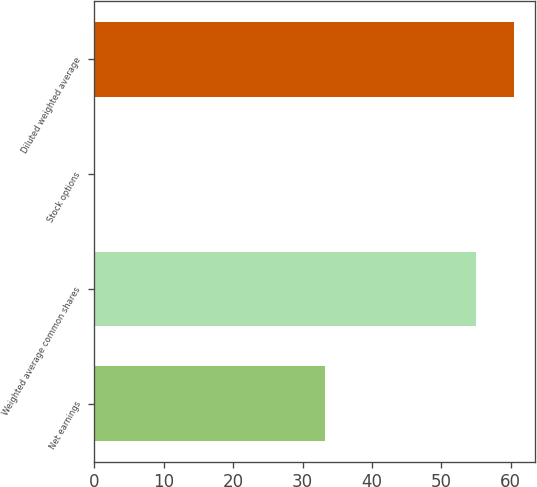Convert chart. <chart><loc_0><loc_0><loc_500><loc_500><bar_chart><fcel>Net earnings<fcel>Weighted average common shares<fcel>Stock options<fcel>Diluted weighted average<nl><fcel>33.3<fcel>55<fcel>0.1<fcel>60.5<nl></chart> 